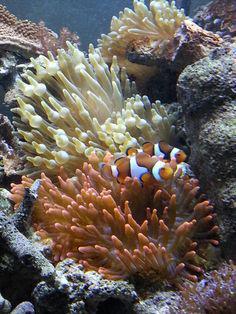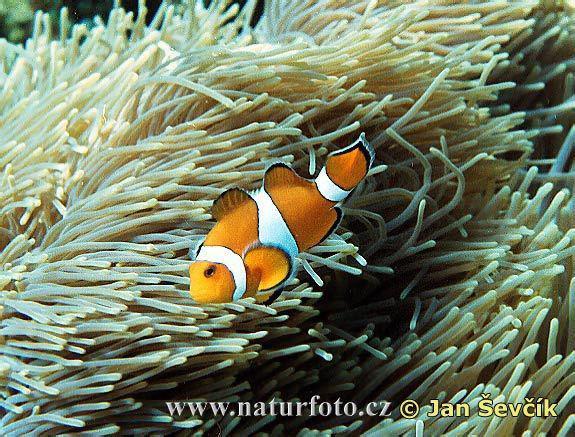The first image is the image on the left, the second image is the image on the right. For the images shown, is this caption "The left and right image contains the same number of fish." true? Answer yes or no. No. The first image is the image on the left, the second image is the image on the right. Assess this claim about the two images: "The left image shows exactly two clown fish close together over anemone, and the right image includes a clown fish over white anemone tendrils.". Correct or not? Answer yes or no. Yes. 